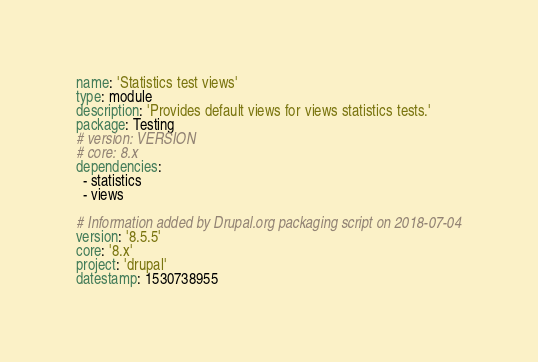<code> <loc_0><loc_0><loc_500><loc_500><_YAML_>name: 'Statistics test views'
type: module
description: 'Provides default views for views statistics tests.'
package: Testing
# version: VERSION
# core: 8.x
dependencies:
  - statistics
  - views

# Information added by Drupal.org packaging script on 2018-07-04
version: '8.5.5'
core: '8.x'
project: 'drupal'
datestamp: 1530738955
</code> 